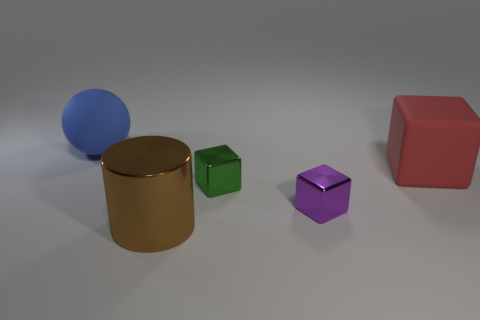Is the shape of the green thing the same as the purple thing?
Provide a short and direct response. Yes. How many blocks are tiny green objects or purple shiny objects?
Make the answer very short. 2. What is the color of the tiny object that is the same material as the purple cube?
Your answer should be very brief. Green. Do the green object that is in front of the red rubber block and the purple object have the same size?
Offer a very short reply. Yes. Do the purple object and the big object that is left of the big brown cylinder have the same material?
Offer a terse response. No. The matte object in front of the rubber sphere is what color?
Offer a very short reply. Red. There is a metal thing that is in front of the purple object; is there a big blue matte object right of it?
Your answer should be compact. No. Do the tiny thing that is behind the small purple shiny cube and the big object that is to the right of the purple thing have the same color?
Provide a succinct answer. No. How many matte blocks are behind the ball?
Give a very brief answer. 0. Is the big thing behind the big red cube made of the same material as the purple object?
Your answer should be very brief. No. 